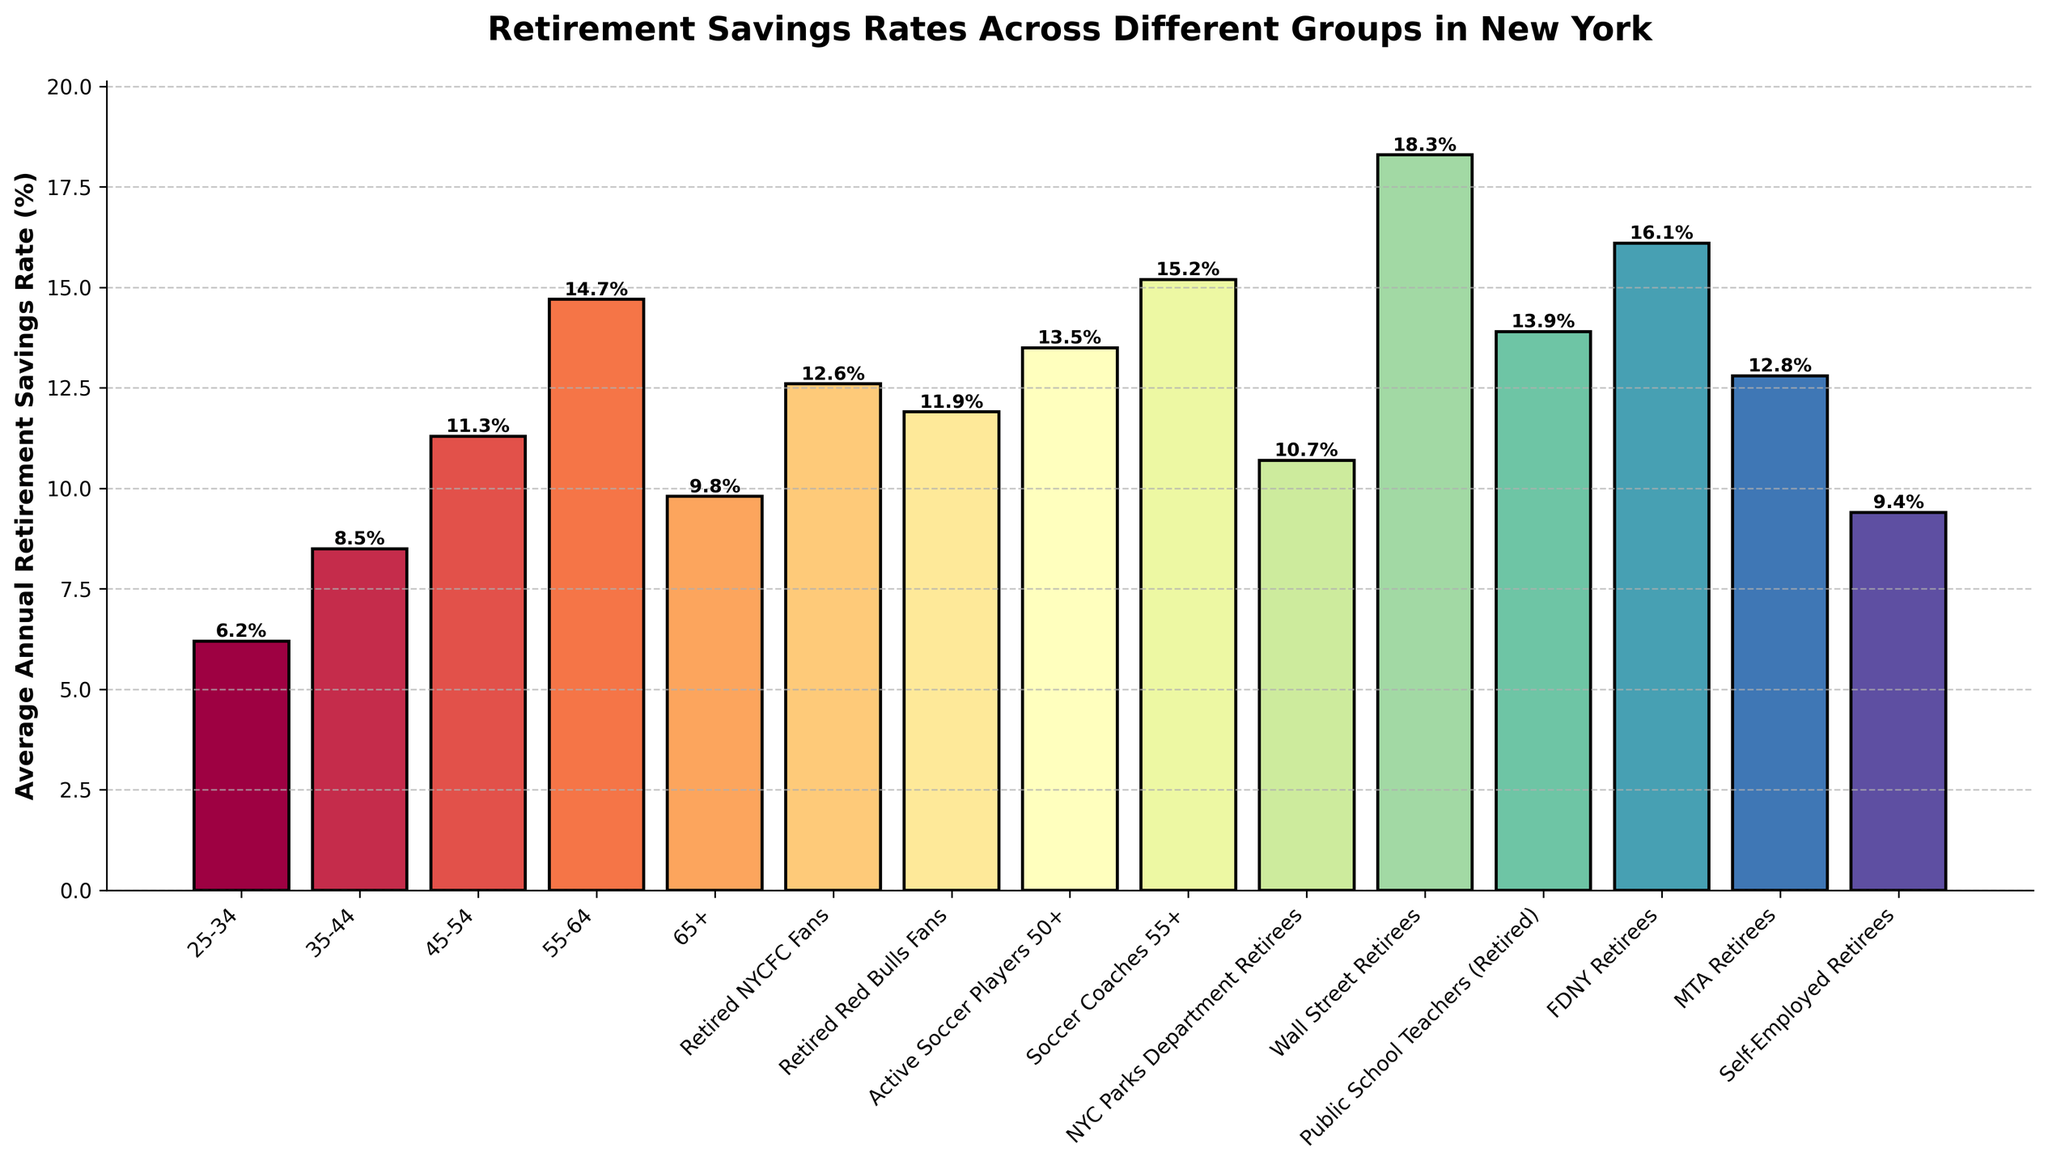What's the average retirement savings rate of Retired NYCFC Fans and Retired Red Bulls Fans? To find the average, sum the retirement savings rates for Retired NYCFC Fans (12.6) and Retired Red Bulls Fans (11.9), which equals 24.5, and then divide by 2. The average is 24.5 / 2 = 12.25.
Answer: 12.25 Which group has the highest average annual retirement savings rate and what is it? By observing the bar chart, Wall Street Retirees have the highest bar, indicating the highest savings rate of 18.3%.
Answer: Wall Street Retirees, 18.3% Who saves more on average, Active Soccer Players 50+ or FDNY Retirees? Compare the heights of the bars for Active Soccer Players 50+ (13.5%) and FDNY Retirees (16.1%). FDNY Retirees have a higher savings rate at 16.1%.
Answer: FDNY Retirees What is the difference in retirement savings rate between Soccer Coaches 55+ and Public School Teachers (Retired)? Subtract the retirement savings rate of Public School Teachers (Retired) from that of Soccer Coaches 55+: 15.2% - 13.9% = 1.3%.
Answer: 1.3% Which age group has a higher average annual retirement savings rate, 45-54 or 65+? Compare the heights of the bars for the age group 45-54 (11.3%) and 65+ (9.8%). The 45-54 age group has a higher savings rate at 11.3%.
Answer: 45-54 What are the third and fourth highest average annual retirement savings rates among all the groups? By observing the heights of the bars in decreasing order, the third-highest rate is 16.1% (FDNY Retirees), and the fourth-highest rate is 15.2% (Soccer Coaches 55+).
Answer: 16.1% and 15.2% If you combine the retirement savings rates of 35-44 and 45-54 age groups, what is their total? Sum the retirement savings rates for 35-44 (8.5%) and 45-54 (11.3%): 8.5 + 11.3 = 19.8%.
Answer: 19.8% Which group of retirees among listed categories has a savings rate similar to Self-Employed Retirees? Compare Self-Employed Retirees' percentage (9.4%) with other groups, finding that the 65+ age group has a similar savings rate (9.8%).
Answer: 65+ Is the retirement savings rate of MTA Retirees higher or lower than Retired NYCFC Fans? Compare the heights of the bars for MTA Retirees (12.8%) and Retired NYCFC Fans (12.6%). MTA Retirees have a slightly higher rate.
Answer: Higher 